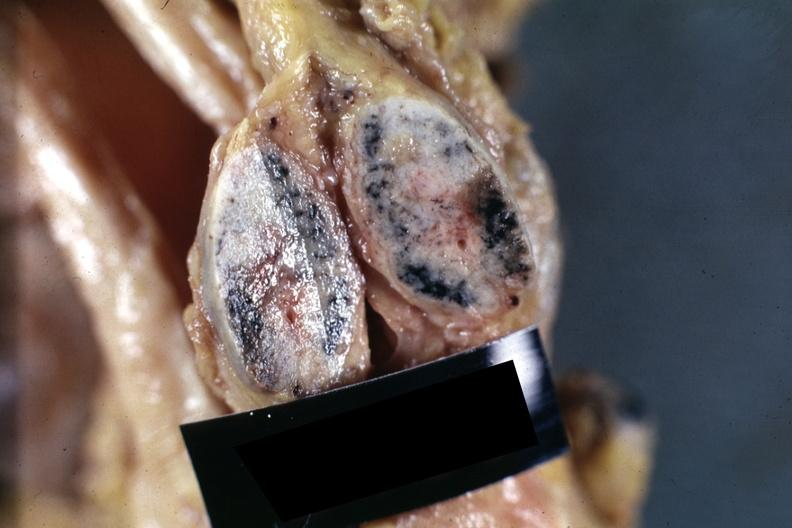what does this image show?
Answer the question using a single word or phrase. Close-up hilar node with anthracotic pigment and metastatic small cell carcinoma from lung good example 